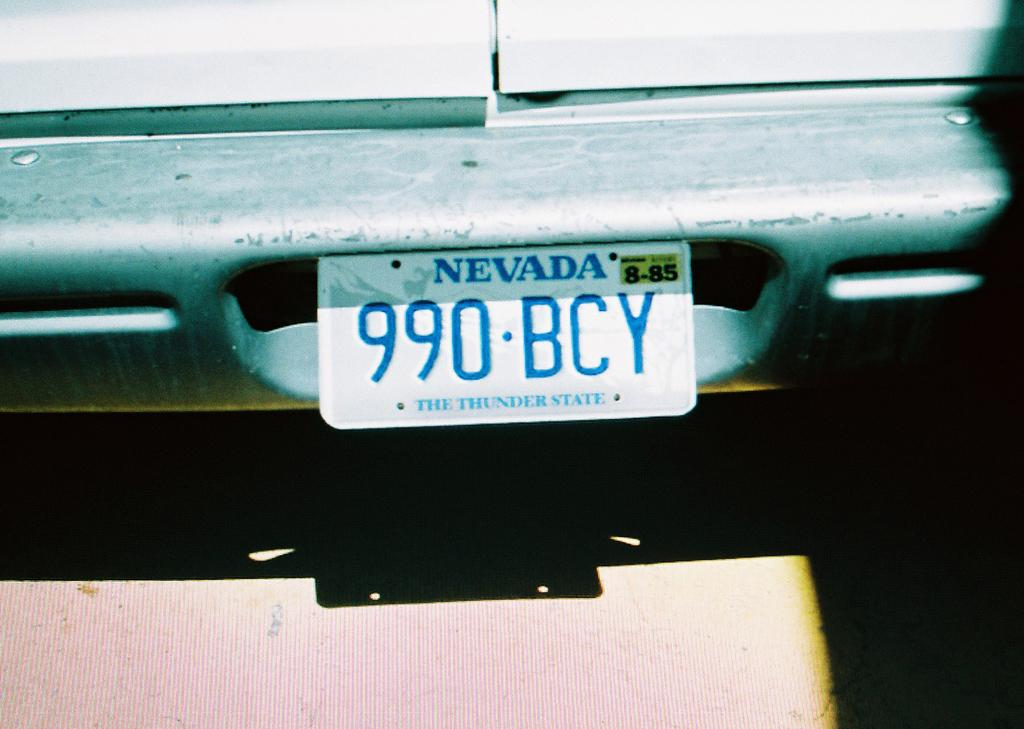Provide a one-sentence caption for the provided image. The car is from Nevada, with license plate number 990 BCY. 